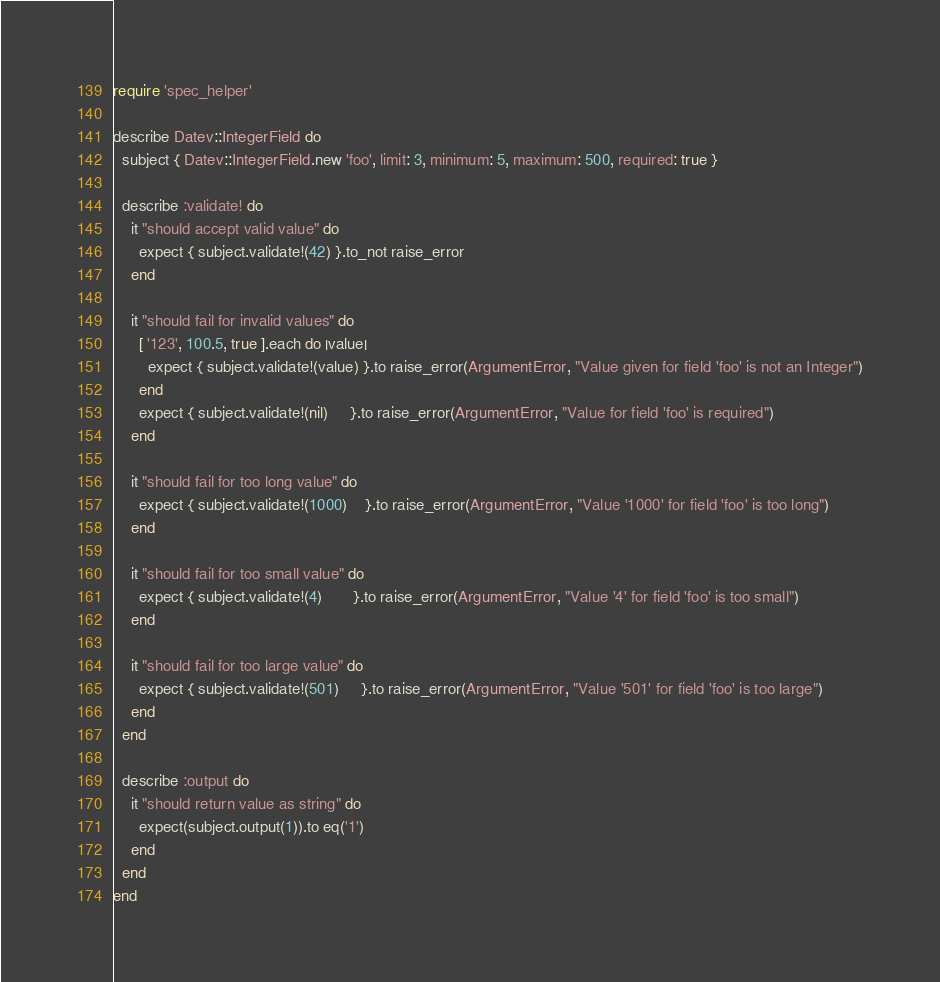<code> <loc_0><loc_0><loc_500><loc_500><_Ruby_>require 'spec_helper'

describe Datev::IntegerField do
  subject { Datev::IntegerField.new 'foo', limit: 3, minimum: 5, maximum: 500, required: true }

  describe :validate! do
    it "should accept valid value" do
      expect { subject.validate!(42) }.to_not raise_error
    end

    it "should fail for invalid values" do
      [ '123', 100.5, true ].each do |value|
        expect { subject.validate!(value) }.to raise_error(ArgumentError, "Value given for field 'foo' is not an Integer")
      end
      expect { subject.validate!(nil)     }.to raise_error(ArgumentError, "Value for field 'foo' is required")
    end

    it "should fail for too long value" do
      expect { subject.validate!(1000)    }.to raise_error(ArgumentError, "Value '1000' for field 'foo' is too long")
    end

    it "should fail for too small value" do
      expect { subject.validate!(4)       }.to raise_error(ArgumentError, "Value '4' for field 'foo' is too small")
    end

    it "should fail for too large value" do
      expect { subject.validate!(501)     }.to raise_error(ArgumentError, "Value '501' for field 'foo' is too large")
    end
  end

  describe :output do
    it "should return value as string" do
      expect(subject.output(1)).to eq('1')
    end
  end
end
</code> 